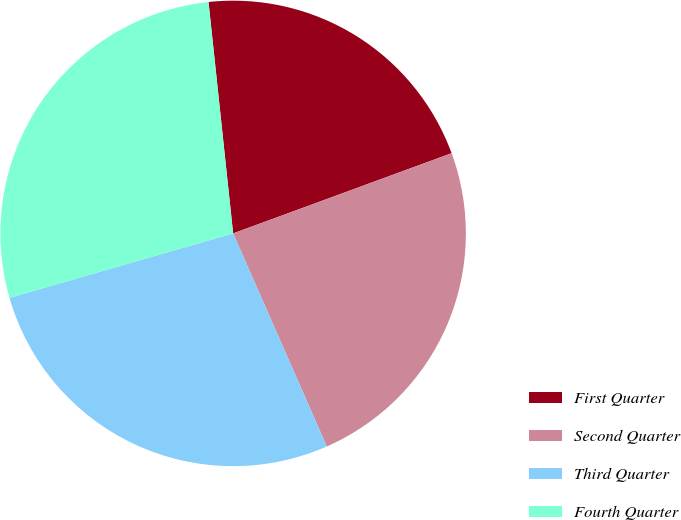<chart> <loc_0><loc_0><loc_500><loc_500><pie_chart><fcel>First Quarter<fcel>Second Quarter<fcel>Third Quarter<fcel>Fourth Quarter<nl><fcel>21.09%<fcel>24.01%<fcel>27.13%<fcel>27.78%<nl></chart> 